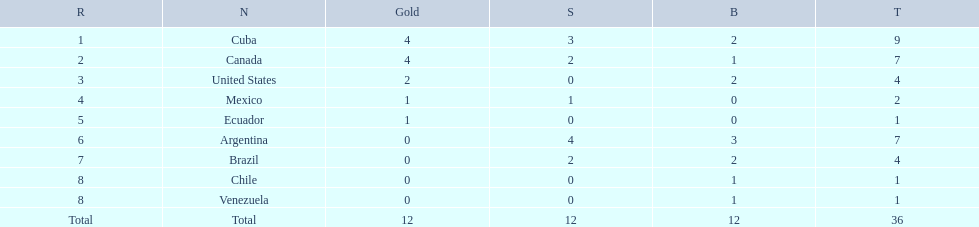Which nations won gold medals? Cuba, Canada, United States, Mexico, Ecuador. How many medals did each nation win? Cuba, 9, Canada, 7, United States, 4, Mexico, 2, Ecuador, 1. Which nation only won a gold medal? Ecuador. 